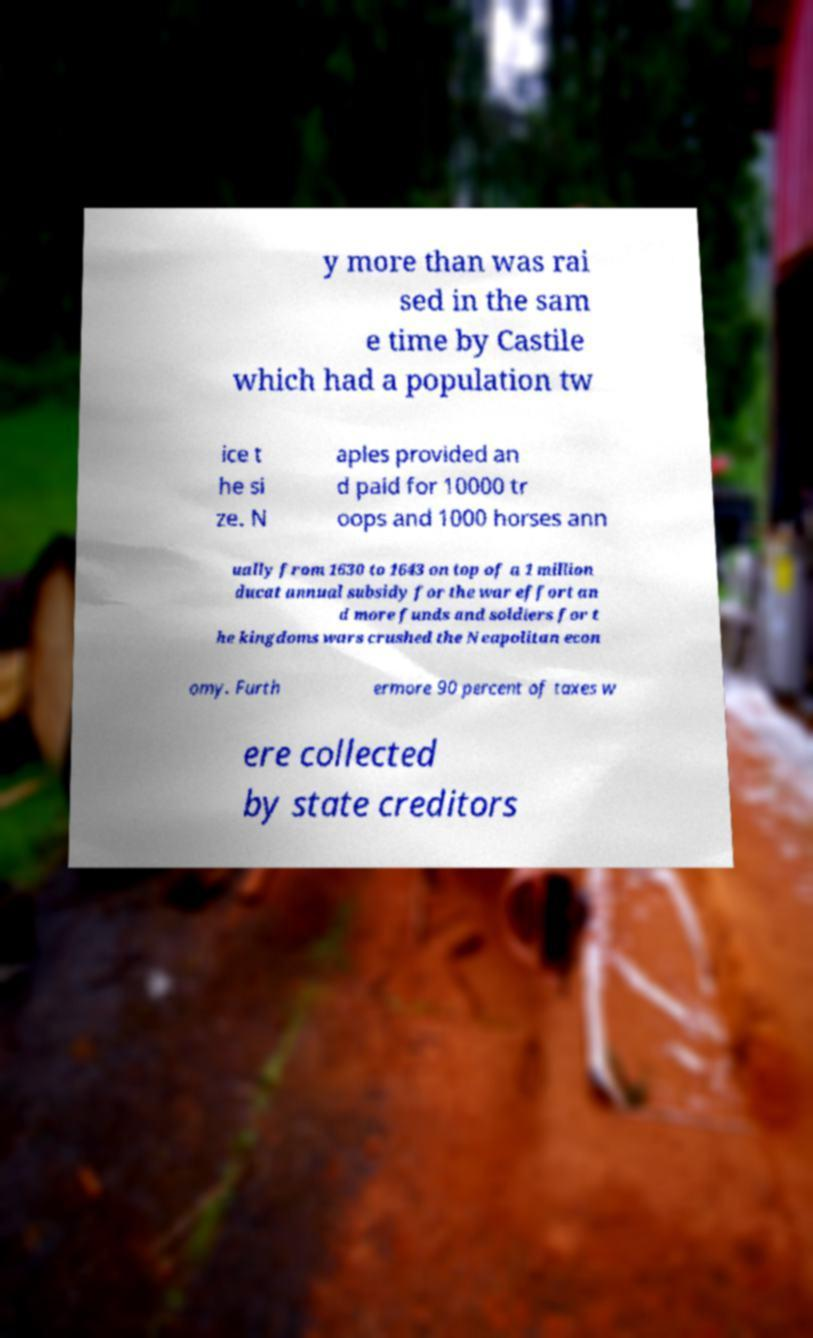For documentation purposes, I need the text within this image transcribed. Could you provide that? y more than was rai sed in the sam e time by Castile which had a population tw ice t he si ze. N aples provided an d paid for 10000 tr oops and 1000 horses ann ually from 1630 to 1643 on top of a 1 million ducat annual subsidy for the war effort an d more funds and soldiers for t he kingdoms wars crushed the Neapolitan econ omy. Furth ermore 90 percent of taxes w ere collected by state creditors 